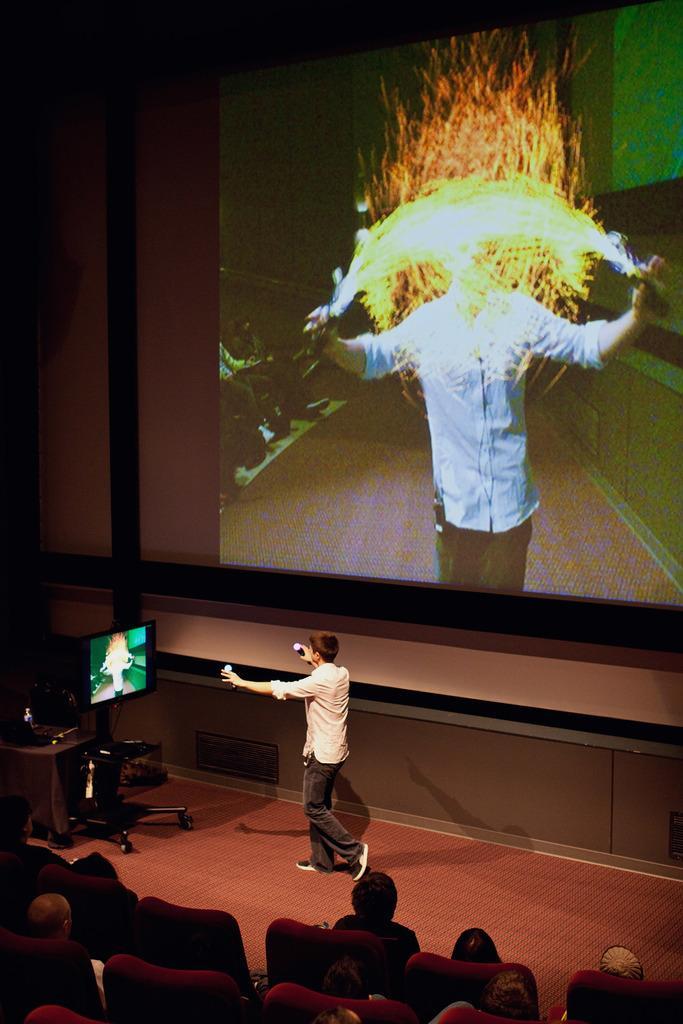Can you describe this image briefly? At the bottom of the image we can see a few people are sitting on the chairs. In the center of the image we can see one table, one stand, one monitor, one person is standing and he is holding some objects and a few other objects. In the background there is a wall, screen and a few other objects. On the screen, we can see a few people are sitting and one person is standing and he is holding some objects. 